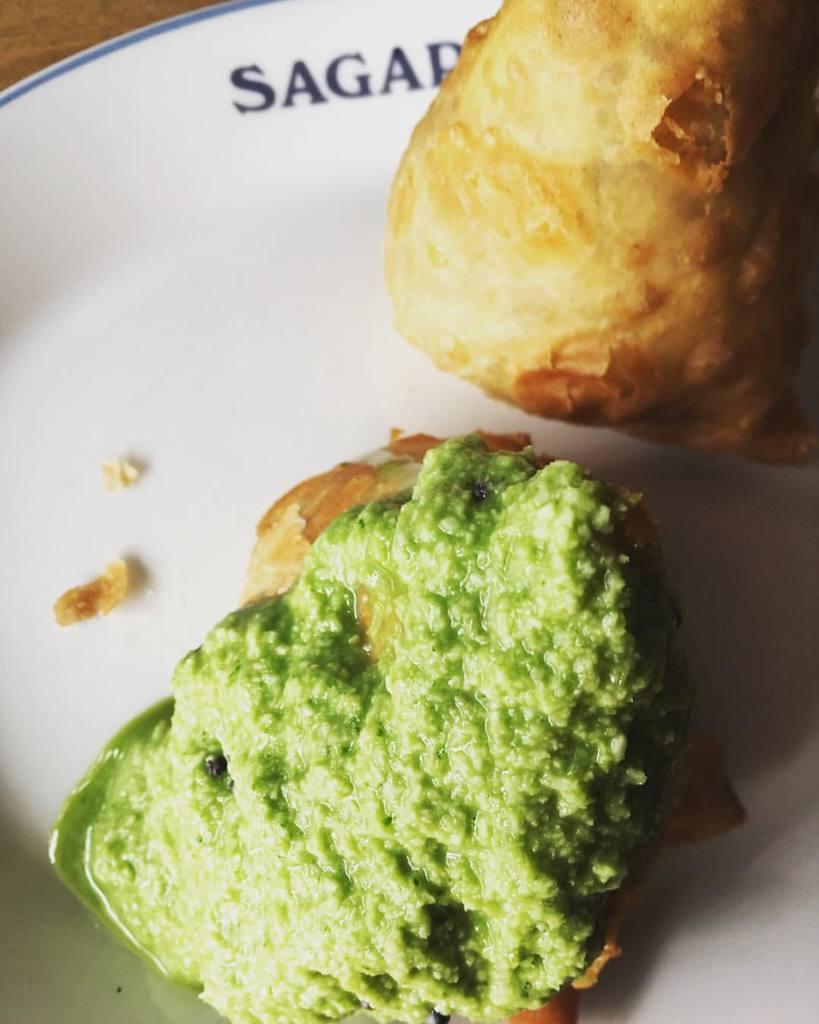Describe this image in one or two sentences. In this image, we can see snacks in the plate. 